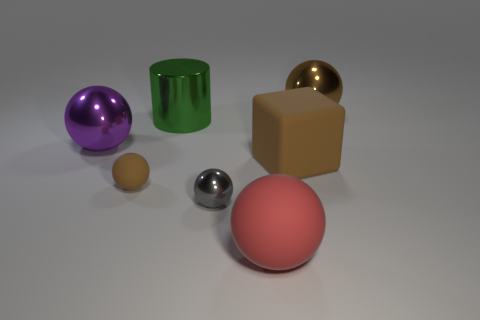Are there any other things that have the same material as the big cube?
Provide a short and direct response. Yes. What color is the big shiny sphere right of the red matte sphere?
Ensure brevity in your answer.  Brown. What is the shape of the brown rubber thing that is the same size as the green shiny thing?
Provide a short and direct response. Cube. Does the large rubber ball have the same color as the metal sphere to the left of the tiny brown matte thing?
Provide a short and direct response. No. What number of things are tiny balls to the left of the cylinder or rubber spheres that are behind the tiny gray shiny sphere?
Your answer should be very brief. 1. What is the material of the brown sphere that is the same size as the cube?
Give a very brief answer. Metal. How many other things are there of the same material as the cylinder?
Offer a terse response. 3. There is a brown matte thing that is to the right of the big red matte ball; does it have the same shape as the large metal object on the right side of the gray object?
Give a very brief answer. No. The metal thing that is on the right side of the matte thing that is in front of the brown matte object to the left of the big brown rubber object is what color?
Offer a terse response. Brown. What number of other objects are the same color as the metal cylinder?
Your answer should be very brief. 0. 